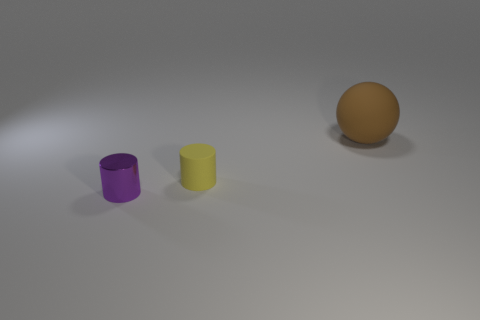Add 3 tiny cyan objects. How many objects exist? 6 Subtract all cylinders. How many objects are left? 1 Subtract 2 cylinders. How many cylinders are left? 0 Add 1 large matte spheres. How many large matte spheres exist? 2 Subtract 0 purple cubes. How many objects are left? 3 Subtract all gray cylinders. Subtract all yellow balls. How many cylinders are left? 2 Subtract all red spheres. How many purple cylinders are left? 1 Subtract all spheres. Subtract all purple metal cylinders. How many objects are left? 1 Add 3 small purple shiny things. How many small purple shiny things are left? 4 